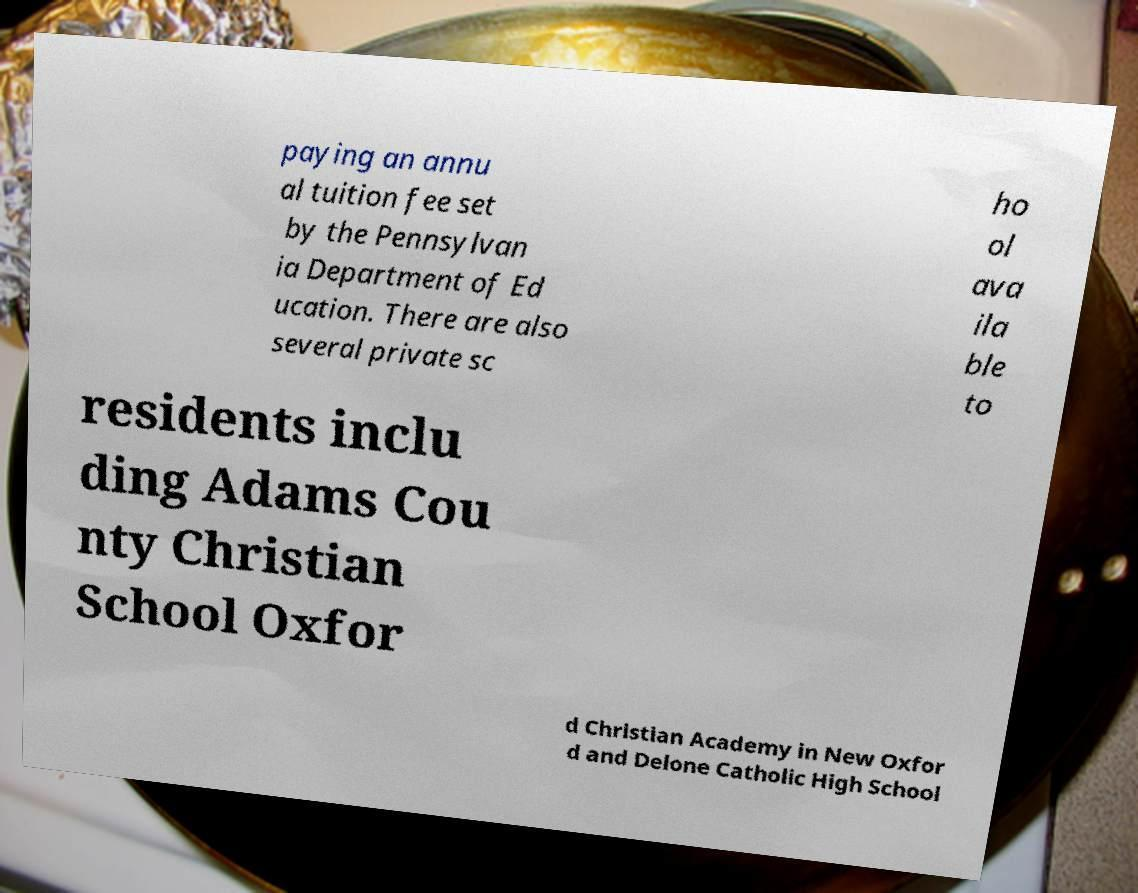Please identify and transcribe the text found in this image. paying an annu al tuition fee set by the Pennsylvan ia Department of Ed ucation. There are also several private sc ho ol ava ila ble to residents inclu ding Adams Cou nty Christian School Oxfor d Christian Academy in New Oxfor d and Delone Catholic High School 